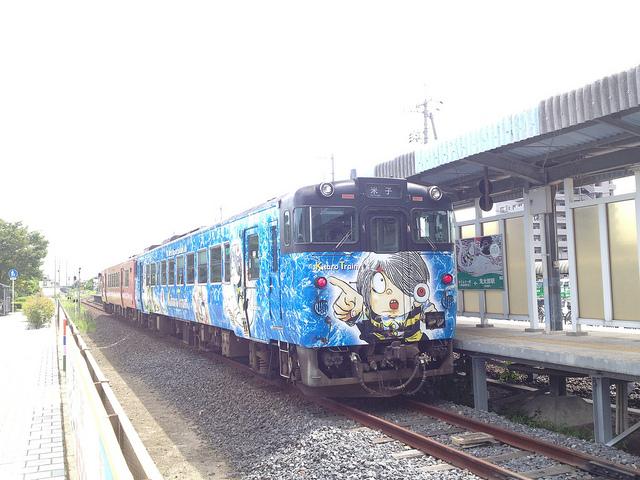Are there any people in the picture?
Give a very brief answer. No. What color is the first car?
Concise answer only. Blue. Is the train stopped?
Write a very short answer. Yes. 